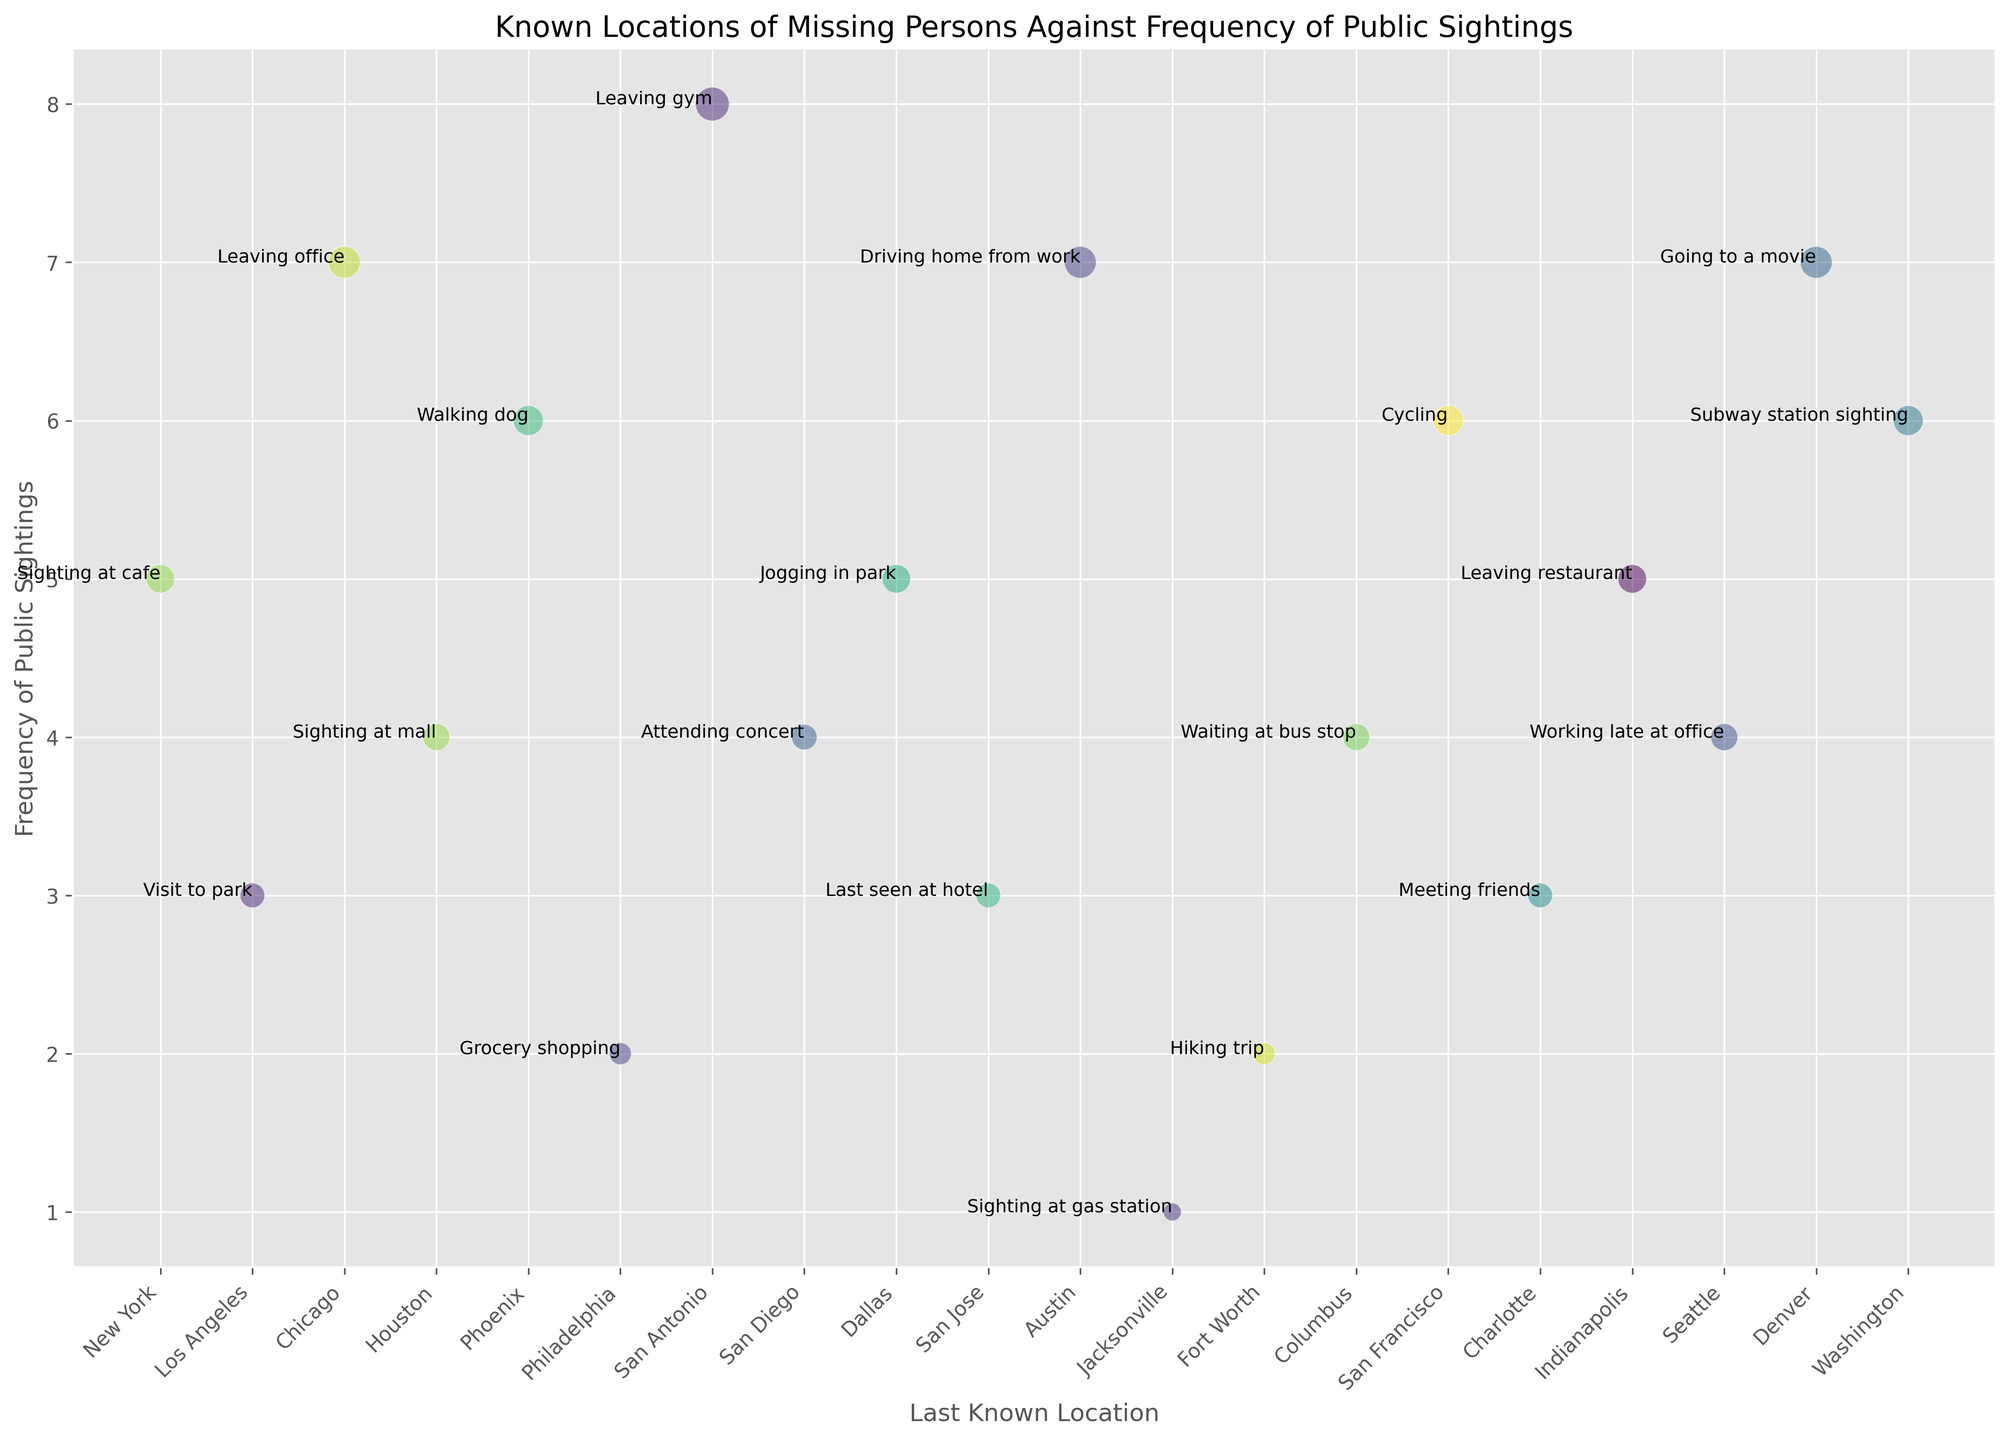What is the location with the highest frequency of public sightings? The highest frequency of public sightings is 8, which belongs to San Antonio.
Answer: San Antonio What is the difference in the frequency of public sightings between Chicago and Philadelphia? Chicago has a frequency of 7, while Philadelphia has a frequency of 2. So the difference is 7 - 2 = 5.
Answer: 5 Which last known activity has the largest bubble size, and where did it occur? The largest bubble size represents a radius of 28, and it is associated with "Leaving gym" in San Antonio.
Answer: Leaving gym, San Antonio How many locations have a frequency of public sightings greater than or equal to 5? The locations with a frequency of public sightings >= 5 are New York (5), Chicago (7), Phoenix (6), San Antonio (8), Dallas (5), Austin (7), San Francisco (6), Denver (7), and Washington (6). There are 9 such locations.
Answer: 9 Which two locations have the smallest bubble sizes and what are their frequencies of public sightings? The smallest bubble sizes represent radii of 8 and 12, which are Jacksonville with a frequency of 1 and both Philadelphia and Fort Worth with a frequency of 2 respectively.
Answer: Jacksonville (1), Philadelphia (2), Fort Worth (2) What is the average radius of the bubbles associated with a frequency of public sightings of 4? The locations with a frequency of 4 are Houston, San Diego, Columbus, and Seattle. Their respective radii are 18, 16, 18, and 18. The average radius is (18 + 16 + 18 + 18) / 4 = 17.5.
Answer: 17.5 Are there more instances of last known activities occurring in parks or at restaurants/cafes? The data shows "Visit to park" in Los Angeles and "Jogging in park" in Dallas for parks (2 instances), and "Sighting at cafe" in New York and "Leaving restaurant" in Indianapolis for restaurants/cafes (2 instances). Both categories have the same number of instances.
Answer: Same (2 each) Which city associated with "Walking dog" has the frequency of public sightings, and what is its corresponding radius? The city associated with "Walking dog" is Phoenix, which has a frequency of public sightings of 6 and a radius of 22.
Answer: Phoenix (6), Radius = 22 